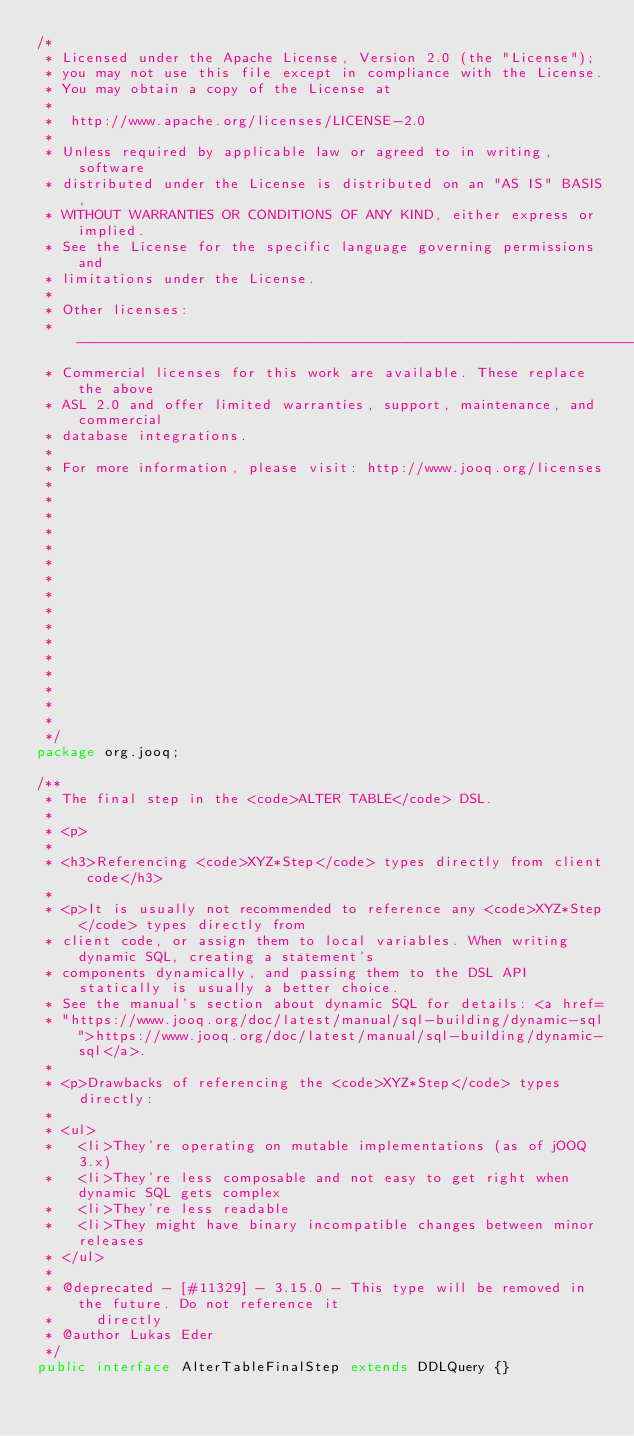Convert code to text. <code><loc_0><loc_0><loc_500><loc_500><_Java_>/* 
 * Licensed under the Apache License, Version 2.0 (the "License");
 * you may not use this file except in compliance with the License.
 * You may obtain a copy of the License at
 *
 *  http://www.apache.org/licenses/LICENSE-2.0
 *
 * Unless required by applicable law or agreed to in writing, software
 * distributed under the License is distributed on an "AS IS" BASIS,
 * WITHOUT WARRANTIES OR CONDITIONS OF ANY KIND, either express or implied.
 * See the License for the specific language governing permissions and
 * limitations under the License.
 *
 * Other licenses:
 * -----------------------------------------------------------------------------
 * Commercial licenses for this work are available. These replace the above
 * ASL 2.0 and offer limited warranties, support, maintenance, and commercial
 * database integrations.
 *
 * For more information, please visit: http://www.jooq.org/licenses
 *
 *
 *
 *
 *
 *
 *
 *
 *
 *
 *
 *
 *
 *
 *
 *
 */
package org.jooq;

/**
 * The final step in the <code>ALTER TABLE</code> DSL.
 *
 * <p>
 *
 * <h3>Referencing <code>XYZ*Step</code> types directly from client code</h3>
 *
 * <p>It is usually not recommended to reference any <code>XYZ*Step</code> types directly from
 * client code, or assign them to local variables. When writing dynamic SQL, creating a statement's
 * components dynamically, and passing them to the DSL API statically is usually a better choice.
 * See the manual's section about dynamic SQL for details: <a href=
 * "https://www.jooq.org/doc/latest/manual/sql-building/dynamic-sql">https://www.jooq.org/doc/latest/manual/sql-building/dynamic-sql</a>.
 *
 * <p>Drawbacks of referencing the <code>XYZ*Step</code> types directly:
 *
 * <ul>
 *   <li>They're operating on mutable implementations (as of jOOQ 3.x)
 *   <li>They're less composable and not easy to get right when dynamic SQL gets complex
 *   <li>They're less readable
 *   <li>They might have binary incompatible changes between minor releases
 * </ul>
 *
 * @deprecated - [#11329] - 3.15.0 - This type will be removed in the future. Do not reference it
 *     directly
 * @author Lukas Eder
 */
public interface AlterTableFinalStep extends DDLQuery {}
</code> 